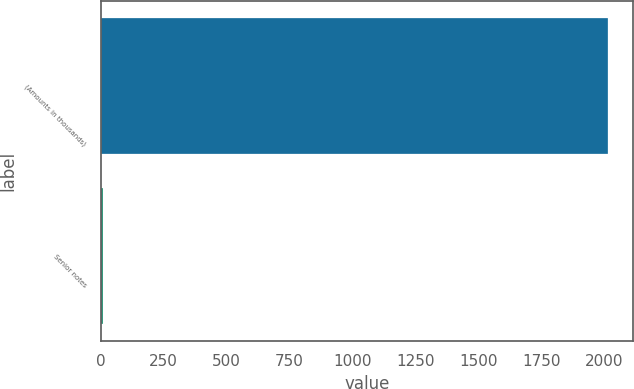Convert chart to OTSL. <chart><loc_0><loc_0><loc_500><loc_500><bar_chart><fcel>(Amounts in thousands)<fcel>Senior notes<nl><fcel>2013<fcel>7.75<nl></chart> 